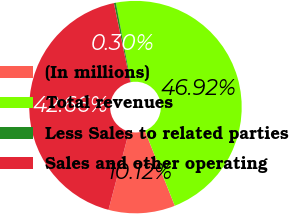<chart> <loc_0><loc_0><loc_500><loc_500><pie_chart><fcel>(In millions)<fcel>Total revenues<fcel>Less Sales to related parties<fcel>Sales and other operating<nl><fcel>10.12%<fcel>46.92%<fcel>0.3%<fcel>42.66%<nl></chart> 